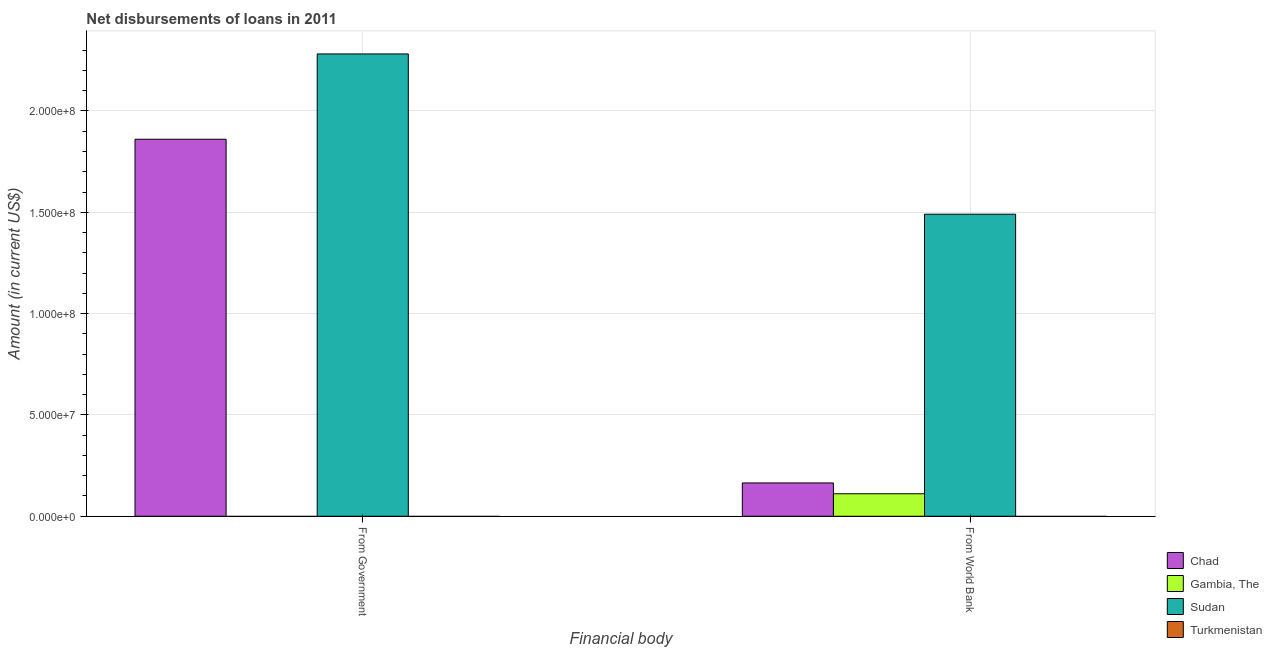How many bars are there on the 1st tick from the left?
Provide a short and direct response. 2. How many bars are there on the 2nd tick from the right?
Your answer should be very brief. 2. What is the label of the 2nd group of bars from the left?
Offer a terse response. From World Bank. What is the net disbursements of loan from government in Chad?
Your answer should be compact. 1.86e+08. Across all countries, what is the maximum net disbursements of loan from world bank?
Make the answer very short. 1.49e+08. Across all countries, what is the minimum net disbursements of loan from world bank?
Your answer should be very brief. 0. In which country was the net disbursements of loan from world bank maximum?
Offer a terse response. Sudan. What is the total net disbursements of loan from government in the graph?
Provide a short and direct response. 4.14e+08. What is the difference between the net disbursements of loan from world bank in Chad and that in Gambia, The?
Make the answer very short. 5.34e+06. What is the difference between the net disbursements of loan from world bank in Turkmenistan and the net disbursements of loan from government in Chad?
Your answer should be compact. -1.86e+08. What is the average net disbursements of loan from government per country?
Your answer should be compact. 1.04e+08. What is the difference between the net disbursements of loan from government and net disbursements of loan from world bank in Sudan?
Your answer should be compact. 7.91e+07. In how many countries, is the net disbursements of loan from government greater than 60000000 US$?
Your answer should be very brief. 2. In how many countries, is the net disbursements of loan from world bank greater than the average net disbursements of loan from world bank taken over all countries?
Provide a succinct answer. 1. How many bars are there?
Offer a very short reply. 5. Are the values on the major ticks of Y-axis written in scientific E-notation?
Provide a short and direct response. Yes. How are the legend labels stacked?
Offer a terse response. Vertical. What is the title of the graph?
Offer a very short reply. Net disbursements of loans in 2011. Does "Myanmar" appear as one of the legend labels in the graph?
Provide a succinct answer. No. What is the label or title of the X-axis?
Your answer should be compact. Financial body. What is the label or title of the Y-axis?
Provide a short and direct response. Amount (in current US$). What is the Amount (in current US$) of Chad in From Government?
Ensure brevity in your answer.  1.86e+08. What is the Amount (in current US$) in Gambia, The in From Government?
Provide a succinct answer. 0. What is the Amount (in current US$) of Sudan in From Government?
Give a very brief answer. 2.28e+08. What is the Amount (in current US$) of Turkmenistan in From Government?
Give a very brief answer. 0. What is the Amount (in current US$) in Chad in From World Bank?
Your answer should be very brief. 1.64e+07. What is the Amount (in current US$) of Gambia, The in From World Bank?
Provide a succinct answer. 1.11e+07. What is the Amount (in current US$) of Sudan in From World Bank?
Make the answer very short. 1.49e+08. Across all Financial body, what is the maximum Amount (in current US$) of Chad?
Ensure brevity in your answer.  1.86e+08. Across all Financial body, what is the maximum Amount (in current US$) in Gambia, The?
Make the answer very short. 1.11e+07. Across all Financial body, what is the maximum Amount (in current US$) in Sudan?
Your answer should be compact. 2.28e+08. Across all Financial body, what is the minimum Amount (in current US$) of Chad?
Your answer should be very brief. 1.64e+07. Across all Financial body, what is the minimum Amount (in current US$) of Gambia, The?
Give a very brief answer. 0. Across all Financial body, what is the minimum Amount (in current US$) in Sudan?
Make the answer very short. 1.49e+08. What is the total Amount (in current US$) in Chad in the graph?
Your response must be concise. 2.02e+08. What is the total Amount (in current US$) of Gambia, The in the graph?
Ensure brevity in your answer.  1.11e+07. What is the total Amount (in current US$) in Sudan in the graph?
Give a very brief answer. 3.77e+08. What is the difference between the Amount (in current US$) in Chad in From Government and that in From World Bank?
Your answer should be compact. 1.70e+08. What is the difference between the Amount (in current US$) of Sudan in From Government and that in From World Bank?
Your response must be concise. 7.91e+07. What is the difference between the Amount (in current US$) of Chad in From Government and the Amount (in current US$) of Gambia, The in From World Bank?
Provide a short and direct response. 1.75e+08. What is the difference between the Amount (in current US$) of Chad in From Government and the Amount (in current US$) of Sudan in From World Bank?
Ensure brevity in your answer.  3.70e+07. What is the average Amount (in current US$) of Chad per Financial body?
Your answer should be very brief. 1.01e+08. What is the average Amount (in current US$) in Gambia, The per Financial body?
Make the answer very short. 5.55e+06. What is the average Amount (in current US$) of Sudan per Financial body?
Keep it short and to the point. 1.89e+08. What is the difference between the Amount (in current US$) in Chad and Amount (in current US$) in Sudan in From Government?
Make the answer very short. -4.21e+07. What is the difference between the Amount (in current US$) in Chad and Amount (in current US$) in Gambia, The in From World Bank?
Your response must be concise. 5.34e+06. What is the difference between the Amount (in current US$) of Chad and Amount (in current US$) of Sudan in From World Bank?
Make the answer very short. -1.33e+08. What is the difference between the Amount (in current US$) in Gambia, The and Amount (in current US$) in Sudan in From World Bank?
Provide a succinct answer. -1.38e+08. What is the ratio of the Amount (in current US$) in Chad in From Government to that in From World Bank?
Offer a very short reply. 11.32. What is the ratio of the Amount (in current US$) in Sudan in From Government to that in From World Bank?
Provide a short and direct response. 1.53. What is the difference between the highest and the second highest Amount (in current US$) in Chad?
Make the answer very short. 1.70e+08. What is the difference between the highest and the second highest Amount (in current US$) in Sudan?
Give a very brief answer. 7.91e+07. What is the difference between the highest and the lowest Amount (in current US$) of Chad?
Ensure brevity in your answer.  1.70e+08. What is the difference between the highest and the lowest Amount (in current US$) in Gambia, The?
Keep it short and to the point. 1.11e+07. What is the difference between the highest and the lowest Amount (in current US$) in Sudan?
Give a very brief answer. 7.91e+07. 